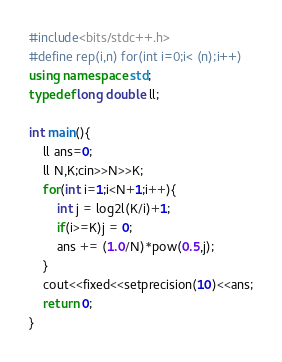<code> <loc_0><loc_0><loc_500><loc_500><_C++_>#include<bits/stdc++.h>
#define rep(i,n) for(int i=0;i< (n);i++)
using namespace std;
typedef long double ll;

int main(){
    ll ans=0;
    ll N,K;cin>>N>>K;
    for(int i=1;i<N+1;i++){
        int j = log2l(K/i)+1;
        if(i>=K)j = 0;
        ans += (1.0/N)*pow(0.5,j);
    }
    cout<<fixed<<setprecision(10)<<ans;
    return 0;
}</code> 